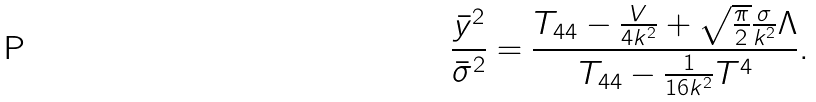Convert formula to latex. <formula><loc_0><loc_0><loc_500><loc_500>\frac { { \bar { y } } ^ { 2 } } { { \bar { \sigma } } ^ { 2 } } = \frac { T _ { 4 4 } - \frac { V } { 4 k ^ { 2 } } + \sqrt { \frac { \pi } { 2 } } \frac { \sigma } { k ^ { 2 } } \Lambda } { T _ { 4 4 } - \frac { 1 } { 1 6 k ^ { 2 } } T ^ { 4 } } .</formula> 